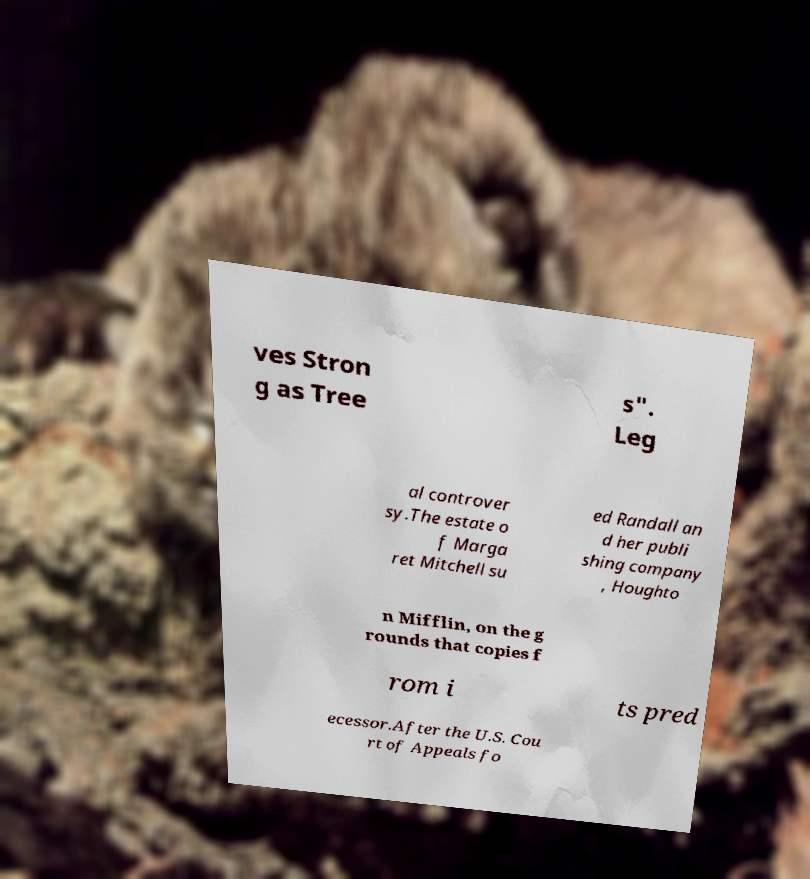For documentation purposes, I need the text within this image transcribed. Could you provide that? ves Stron g as Tree s". Leg al controver sy.The estate o f Marga ret Mitchell su ed Randall an d her publi shing company , Houghto n Mifflin, on the g rounds that copies f rom i ts pred ecessor.After the U.S. Cou rt of Appeals fo 